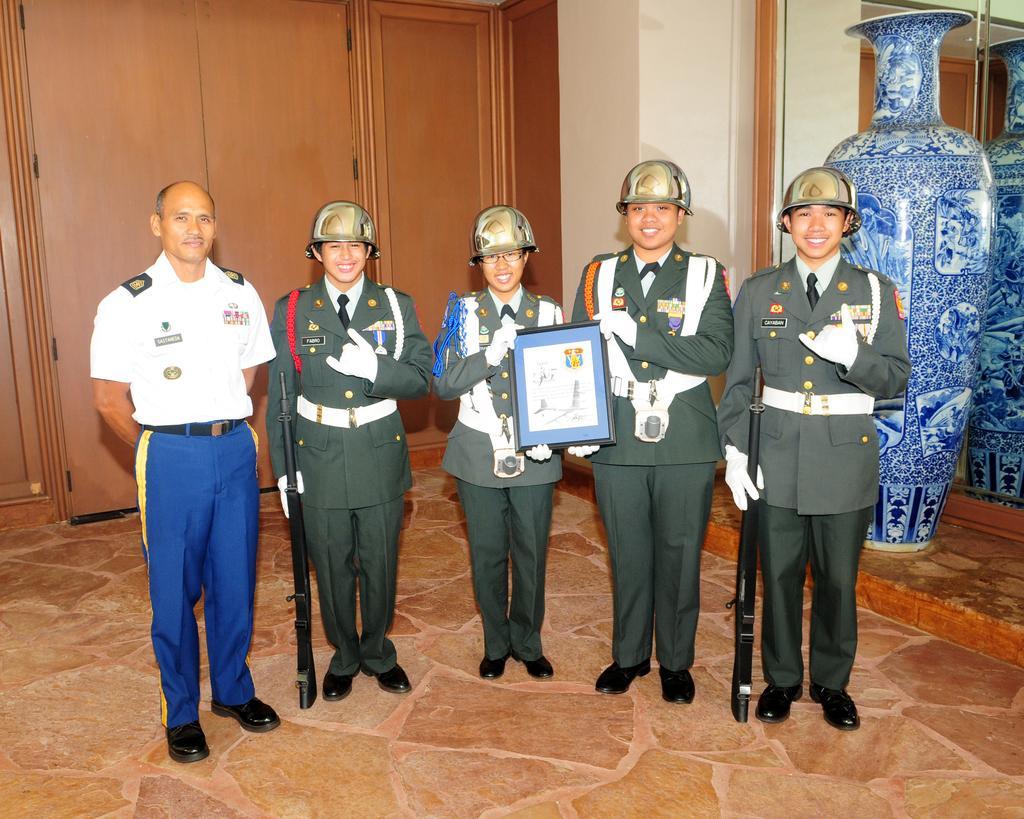Can you describe this image briefly? There are five people standing and these two people holding guns and these two persons are holding frame. Background we can see wall,mirror and vase. 